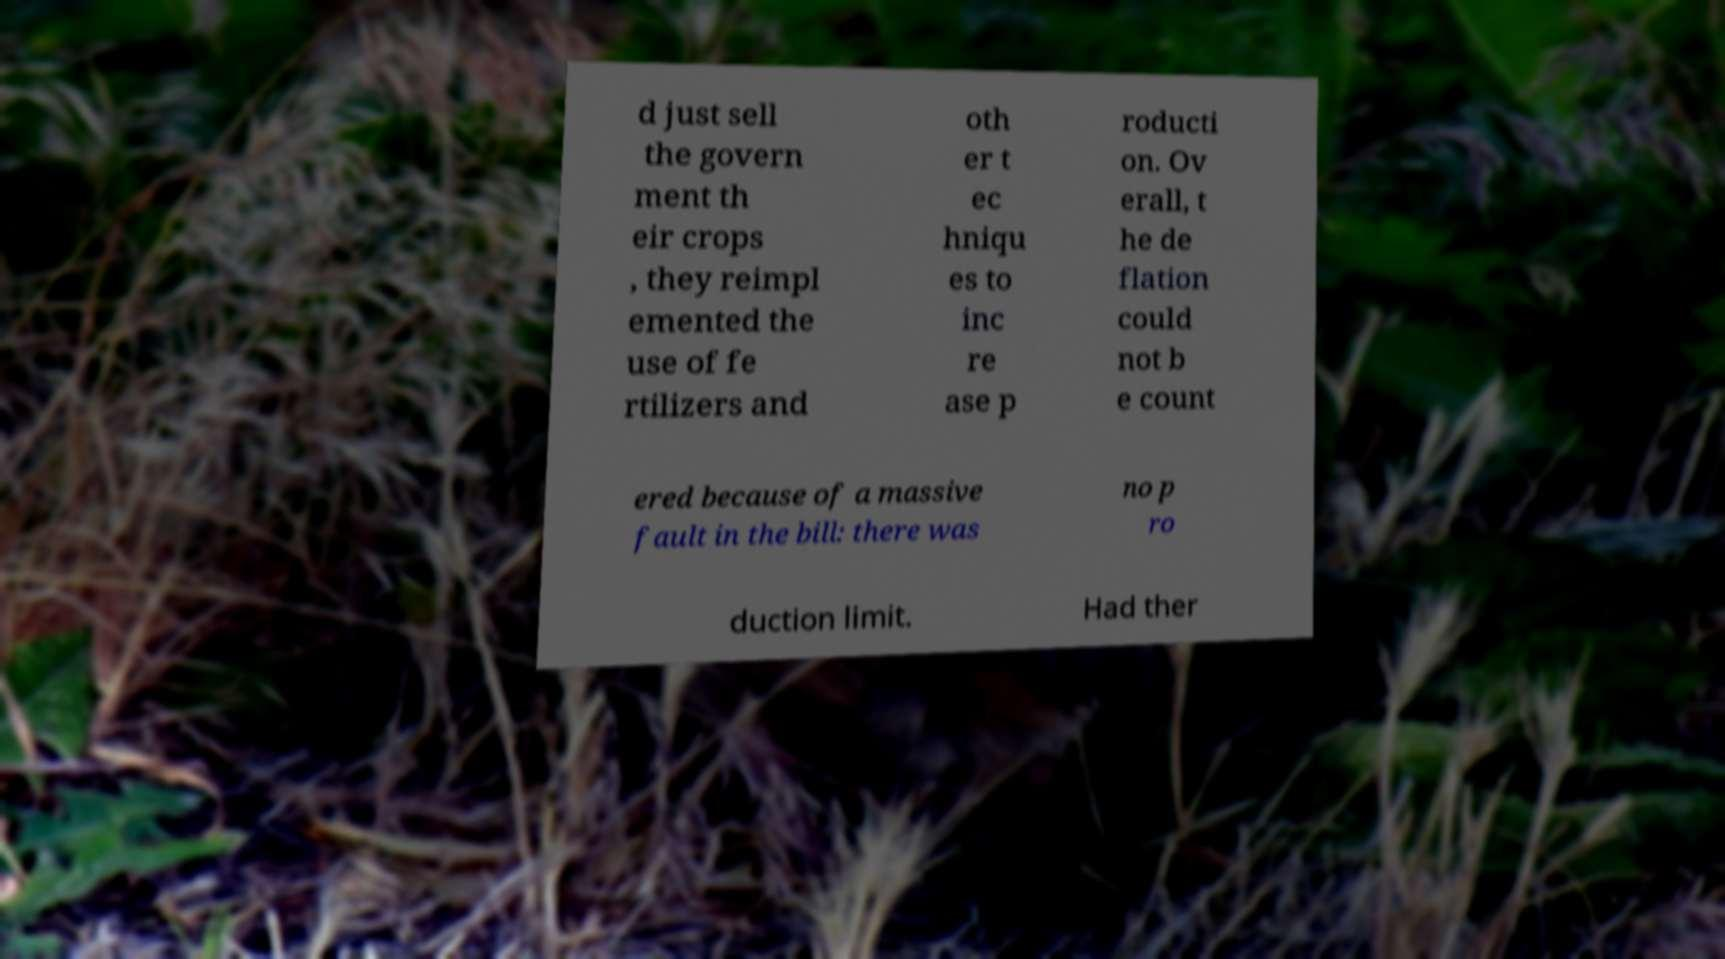Can you read and provide the text displayed in the image?This photo seems to have some interesting text. Can you extract and type it out for me? d just sell the govern ment th eir crops , they reimpl emented the use of fe rtilizers and oth er t ec hniqu es to inc re ase p roducti on. Ov erall, t he de flation could not b e count ered because of a massive fault in the bill: there was no p ro duction limit. Had ther 